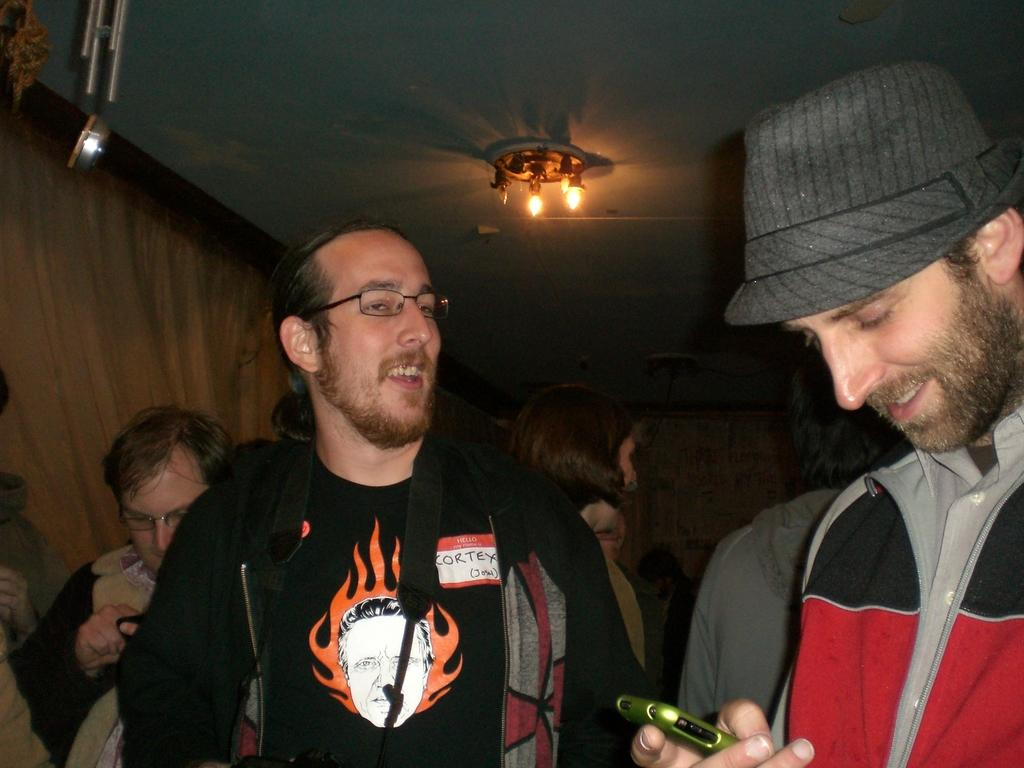How many people are in the image? There are people in the image, but the exact number is not specified. What is the man wearing on his head? The man is wearing a cap. What is the man holding in his hand? The man is holding a mobile. What is the man's facial expression? The man is smiling. What can be seen in the background of the image? There are lights, a wall, and objects in the background of the image. Can you tell me how many pages the man is turning in the image? There is no indication in the image that the man is turning any pages, as he is holding a mobile. What type of coastline is visible in the image? There is no coastline visible in the image; it features people, a man with a cap and a mobile, and a background with lights, a wall, and objects. 